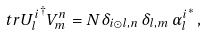<formula> <loc_0><loc_0><loc_500><loc_500>\ t r { { U ^ { i } _ { l } } ^ { \dagger } V _ { m } ^ { n } } = N \delta _ { i \odot l , n } \, \delta _ { l , m } \, { \alpha ^ { i } _ { l } } ^ { * } \, ,</formula> 